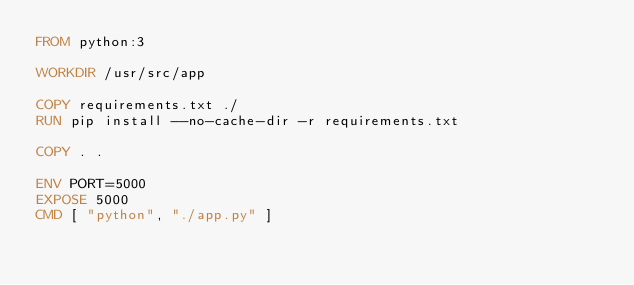<code> <loc_0><loc_0><loc_500><loc_500><_Dockerfile_>FROM python:3

WORKDIR /usr/src/app

COPY requirements.txt ./
RUN pip install --no-cache-dir -r requirements.txt

COPY . .

ENV PORT=5000
EXPOSE 5000
CMD [ "python", "./app.py" ]
</code> 